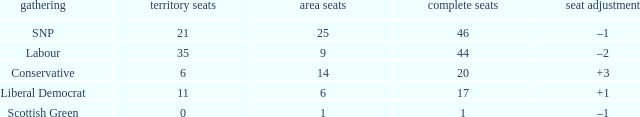How many regional seats were there with the SNP party and where the number of total seats was bigger than 46? 0.0. 